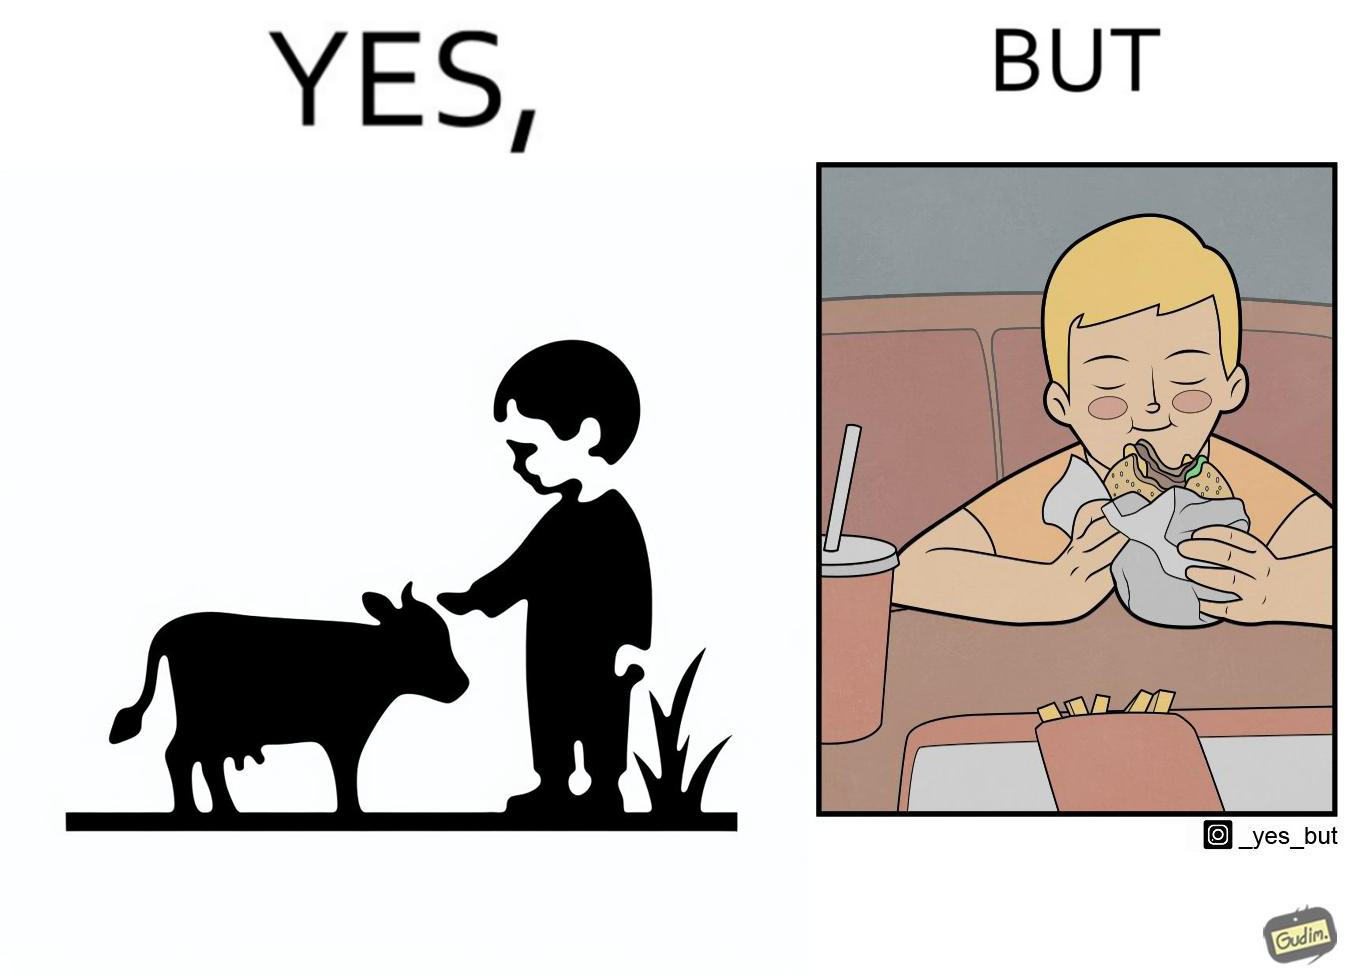Does this image contain satire or humor? Yes, this image is satirical. 